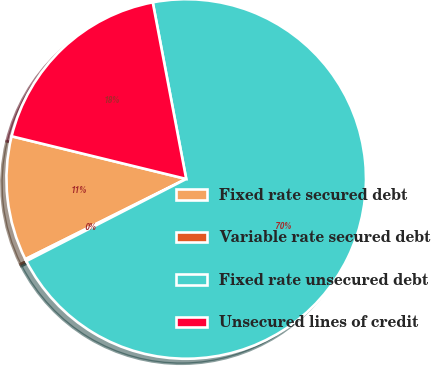Convert chart. <chart><loc_0><loc_0><loc_500><loc_500><pie_chart><fcel>Fixed rate secured debt<fcel>Variable rate secured debt<fcel>Fixed rate unsecured debt<fcel>Unsecured lines of credit<nl><fcel>11.18%<fcel>0.19%<fcel>70.42%<fcel>18.2%<nl></chart> 